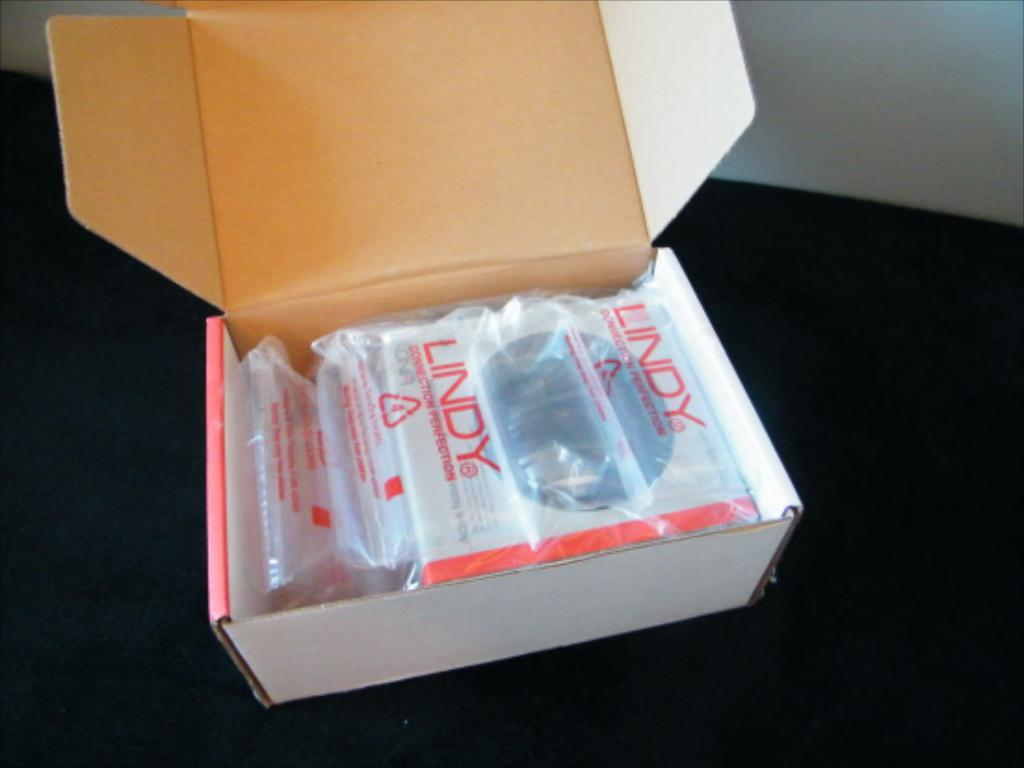<image>
Summarize the visual content of the image. A white box with plastic wrap that says Lindy. 